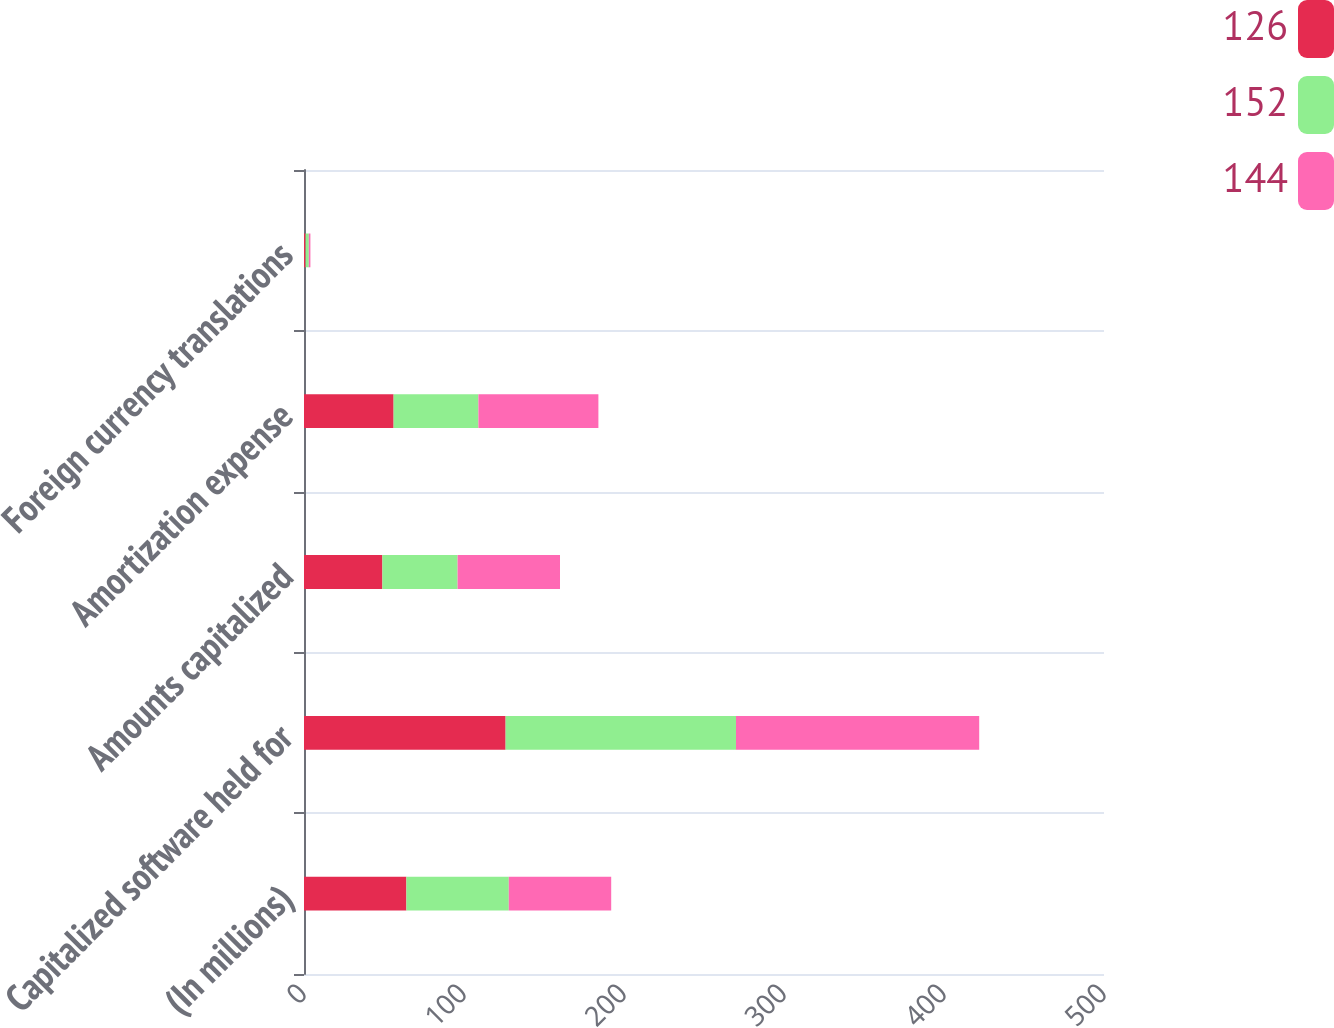Convert chart to OTSL. <chart><loc_0><loc_0><loc_500><loc_500><stacked_bar_chart><ecel><fcel>(In millions)<fcel>Capitalized software held for<fcel>Amounts capitalized<fcel>Amortization expense<fcel>Foreign currency translations<nl><fcel>126<fcel>64<fcel>126<fcel>49<fcel>56<fcel>1<nl><fcel>152<fcel>64<fcel>144<fcel>47<fcel>53<fcel>2<nl><fcel>144<fcel>64<fcel>152<fcel>64<fcel>75<fcel>1<nl></chart> 